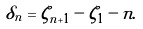<formula> <loc_0><loc_0><loc_500><loc_500>\delta _ { n } = \zeta _ { n + 1 } - \zeta _ { 1 } - n .</formula> 